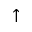<formula> <loc_0><loc_0><loc_500><loc_500>\uparrow</formula> 